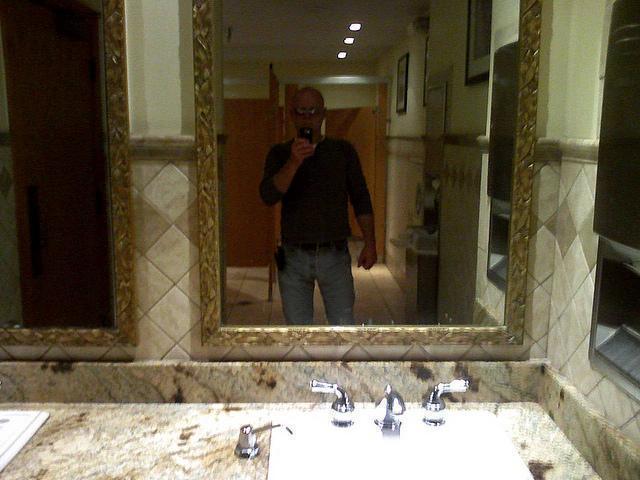Where does the man carry his cell phone?
From the following four choices, select the correct answer to address the question.
Options: Shirt pocket, jeans pocket, messenger bag, side holster. Side holster. 